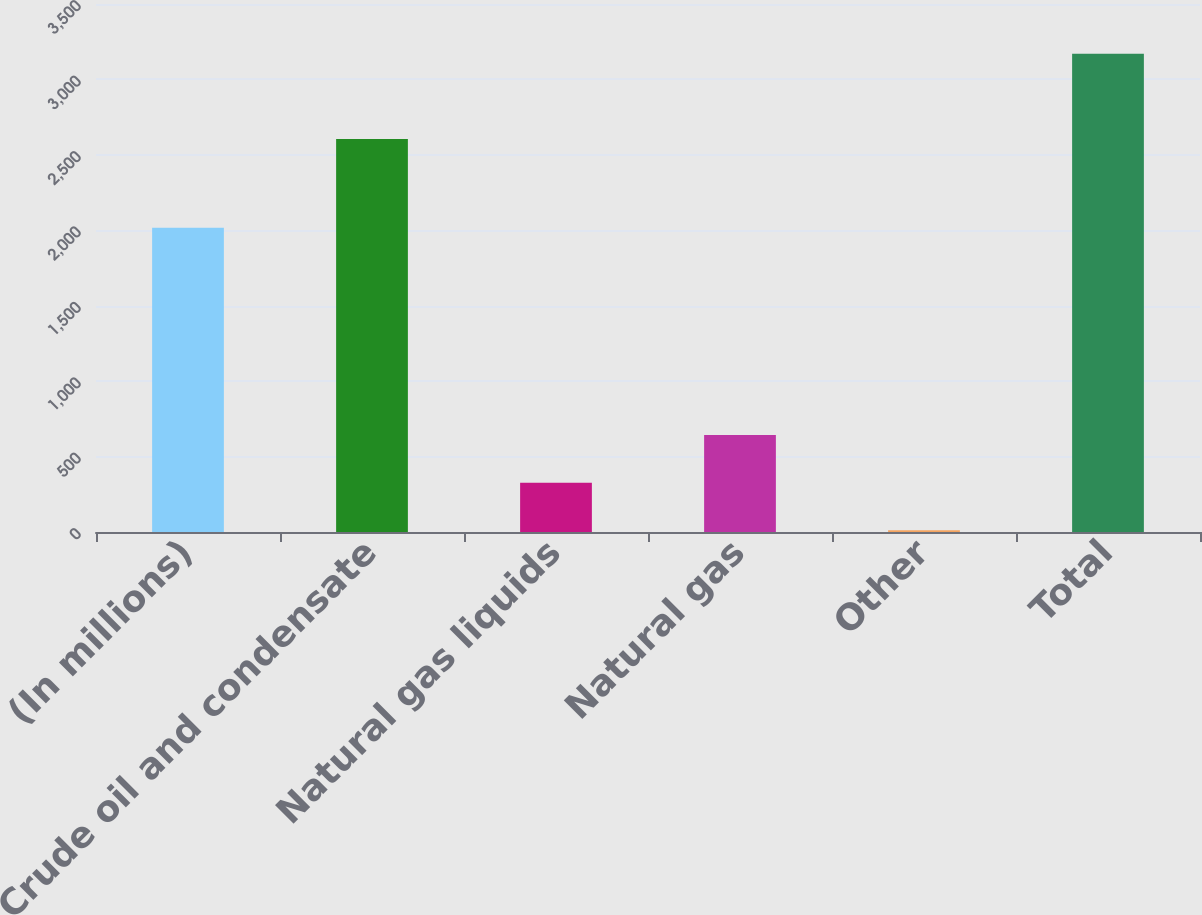Convert chart. <chart><loc_0><loc_0><loc_500><loc_500><bar_chart><fcel>(In millions)<fcel>Crude oil and condensate<fcel>Natural gas liquids<fcel>Natural gas<fcel>Other<fcel>Total<nl><fcel>2016<fcel>2605<fcel>326.9<fcel>642.8<fcel>11<fcel>3170<nl></chart> 